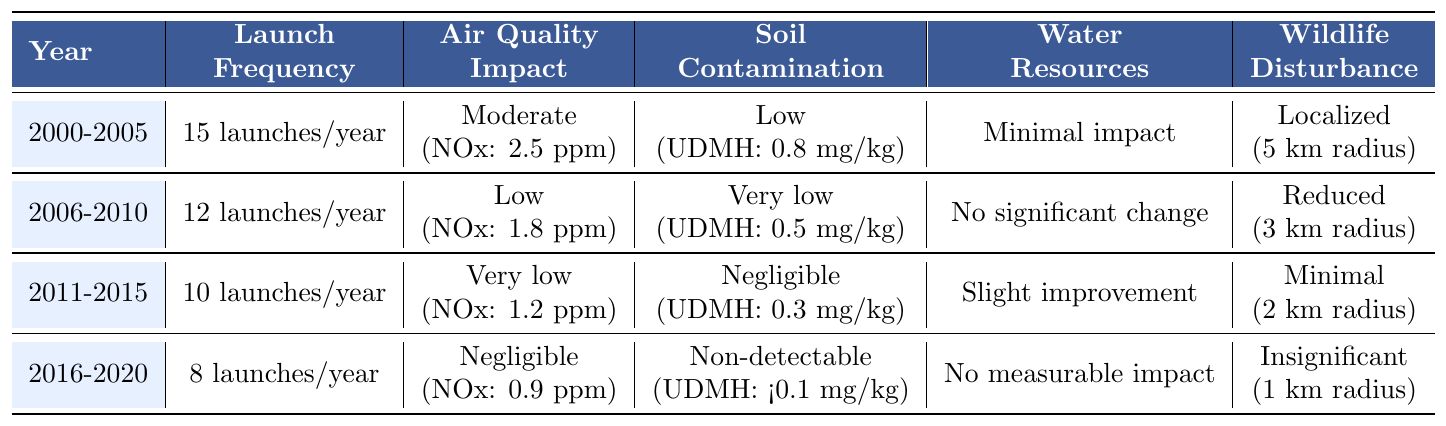What was the launch frequency in 2011-2015? Referring to the table, the launch frequency in the year range of 2011-2015 is listed as 10 launches/year.
Answer: 10 launches/year How did soil contamination change from 2000-2005 to 2016-2020? Looking at the table, soil contamination in 2000-2005 was Low (0.8 mg/kg), whereas in 2016-2020 it became Non-detectable (<0.1 mg/kg). This indicates a significant reduction.
Answer: Soil contamination decreased from Low to Non-detectable Was there a measurable impact on water resources in 2006-2010? The table indicates 'No significant change' for water resources during 2006-2010.
Answer: No What is the average number of launches per year over the entire time period? Adding the launches for each period: (15 + 12 + 10 + 8) = 45 total launches over 4 periods, resulting in the average being 45/4 = 11.25 launches/year.
Answer: 11.25 launches/year Did the air quality impact improve from 2006-2010 to 2011-2015? In 2006-2010, the air quality impact was Low (NOx: 1.8 ppm), and in 2011-2015 it improved to Very low (NOx: 1.2 ppm). Therefore, yes, it did improve.
Answer: Yes, it improved What is the reduction in wildlife disturbance from 2000-2005 to 2016-2020? In 2000-2005, wildlife disturbance was localized at a 5 km radius, while in 2016-2020 it was insignificant at a 1 km radius. This represents a reduction of 4 km.
Answer: 4 km reduction What can be inferred about air quality trends between 2000-2020? Analyzing the data, air quality improved consistently from Moderate (2.5 ppm) in 2000-2005 to Negligible (0.9 ppm) in 2016-2020, indicating a positive trend over the years.
Answer: Air quality improved Is there any significant difference in launch frequency between 2006-2010 and 2011-2015? The launch frequency in 2006-2010 was 12 launches/year and it decreased to 10 launches/year in 2011-2015. Yes, there is a difference of 2 launches/year.
Answer: Yes, a difference of 2 launches/year What was the trend in soil contamination from 2000-2005 to 2011-2015? The table shows a decline in soil contamination from Low (0.8 mg/kg) in 2000-2005 to Negligible (0.3 mg/kg) in 2011-2015, indicating a positive trend toward lower contamination levels.
Answer: The trend was downward, indicating improvement 